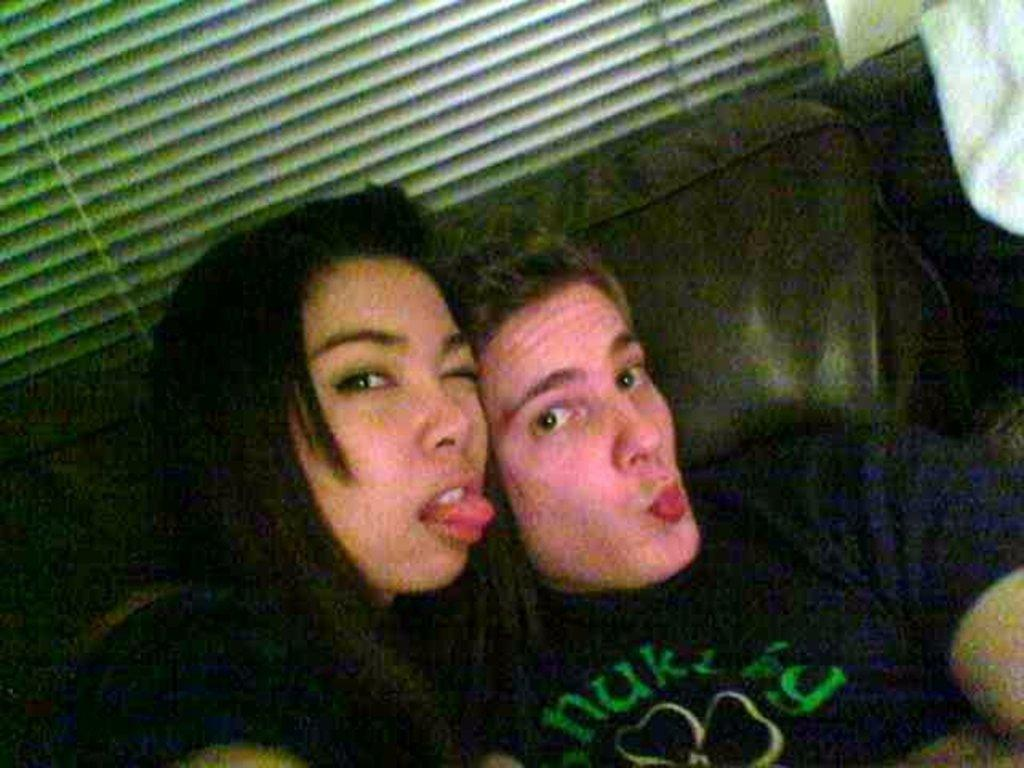Who are the people in the foreground of the image? There is a woman and a man in the foreground of the image. What are they doing in the image? They are posing for the camera. Where are they sitting in the image? They are sitting on a couch. What can be seen in the background of the image? There is a window blind in the background of the image. How many frogs are sitting on the map in the image? There is no map or frogs present in the image. What type of balance do the woman and man need to maintain while sitting on the couch? The image does not show any need for balance while sitting on the couch. 